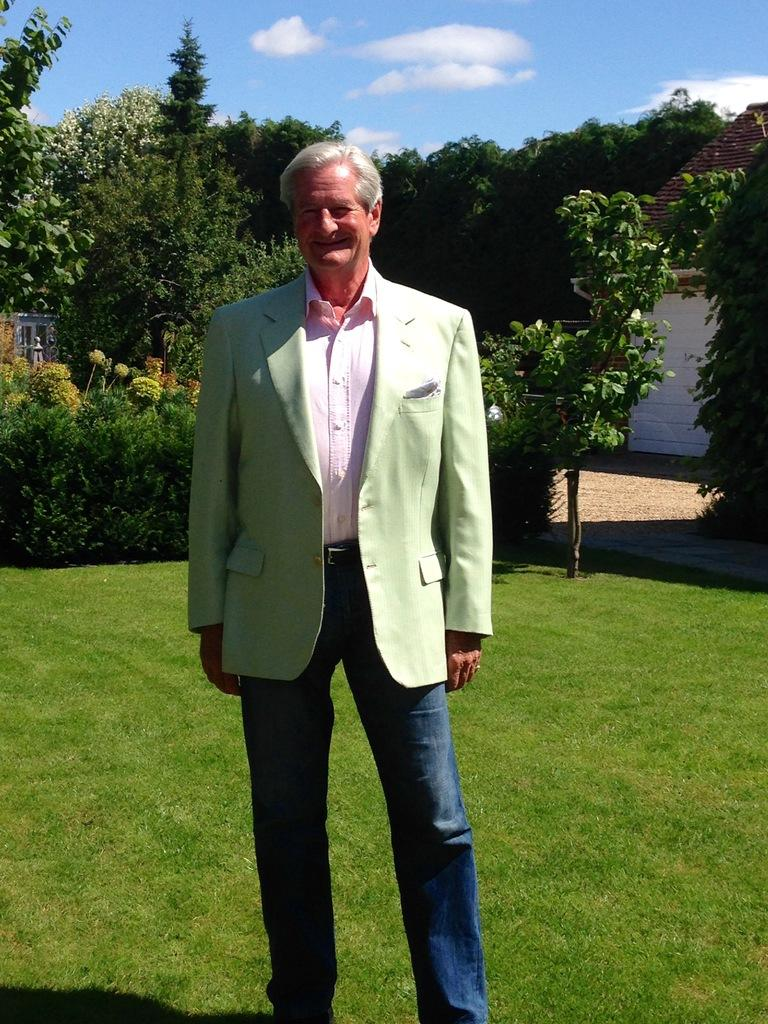What is the main subject of the image? There is a person standing in the center of the image. What is the person wearing? The person is wearing a blazer. What type of terrain is visible at the bottom of the image? There is grass at the bottom of the image. What can be seen in the background of the image? There are trees, a house, and the sky visible in the background of the image. What type of paint is being used by the person in the image? There is no paint or painting activity visible in the image. What country is the person in the image from? The image does not provide any information about the person's nationality or country of origin. 